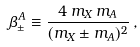<formula> <loc_0><loc_0><loc_500><loc_500>\beta _ { \pm } ^ { A } \equiv \frac { 4 \, m _ { X } \, m _ { A } } { ( m _ { X } \pm m _ { A } ) ^ { 2 } } \, ,</formula> 